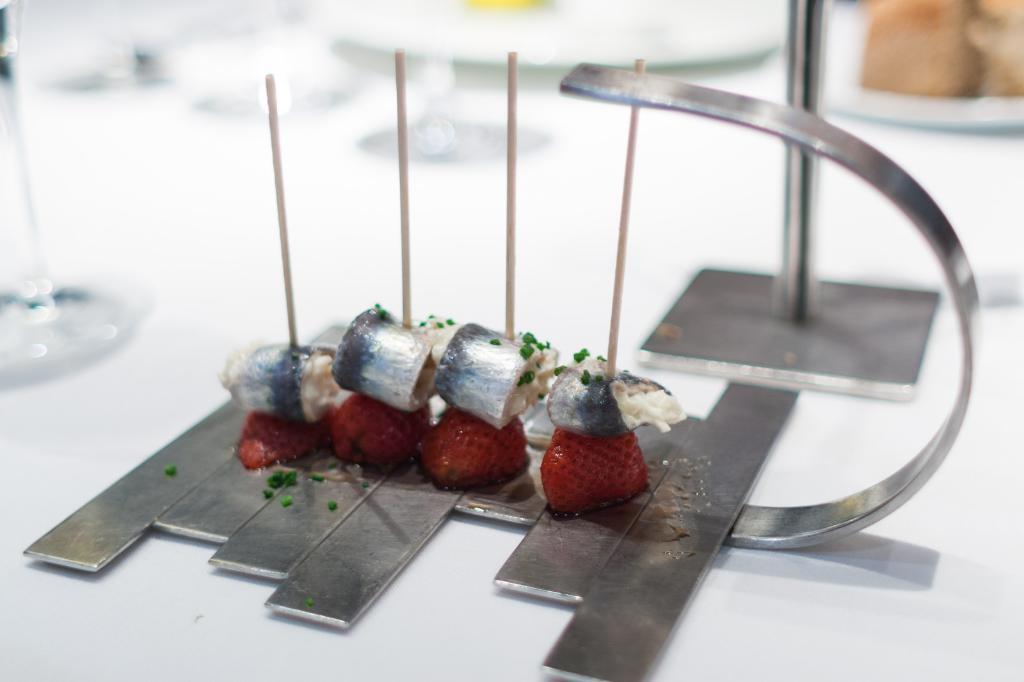Could you give a brief overview of what you see in this image? There is a food item on a white table. There is a glass at the left. At the back there are other food items. 